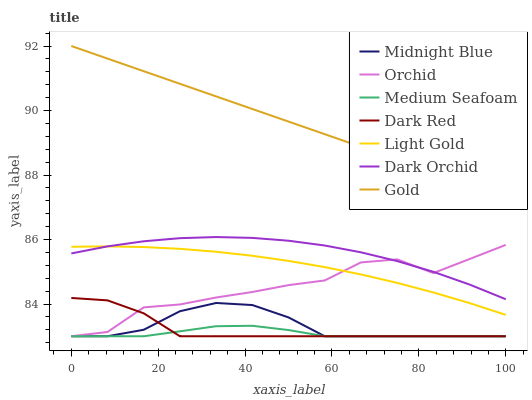Does Dark Red have the minimum area under the curve?
Answer yes or no. No. Does Dark Red have the maximum area under the curve?
Answer yes or no. No. Is Dark Red the smoothest?
Answer yes or no. No. Is Dark Red the roughest?
Answer yes or no. No. Does Gold have the lowest value?
Answer yes or no. No. Does Dark Red have the highest value?
Answer yes or no. No. Is Medium Seafoam less than Light Gold?
Answer yes or no. Yes. Is Gold greater than Dark Orchid?
Answer yes or no. Yes. Does Medium Seafoam intersect Light Gold?
Answer yes or no. No. 